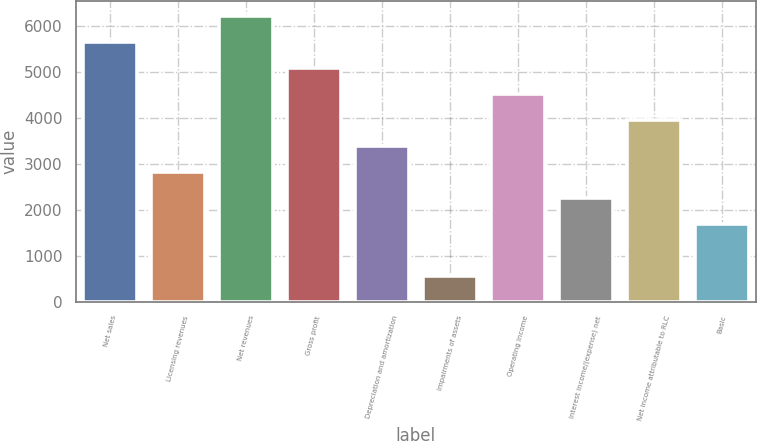<chart> <loc_0><loc_0><loc_500><loc_500><bar_chart><fcel>Net sales<fcel>Licensing revenues<fcel>Net revenues<fcel>Gross profit<fcel>Depreciation and amortization<fcel>Impairments of assets<fcel>Operating income<fcel>Interest income/(expense) net<fcel>Net income attributable to RLC<fcel>Basic<nl><fcel>5660.3<fcel>2830.4<fcel>6226.28<fcel>5094.32<fcel>3396.38<fcel>566.48<fcel>4528.34<fcel>2264.42<fcel>3962.36<fcel>1698.44<nl></chart> 